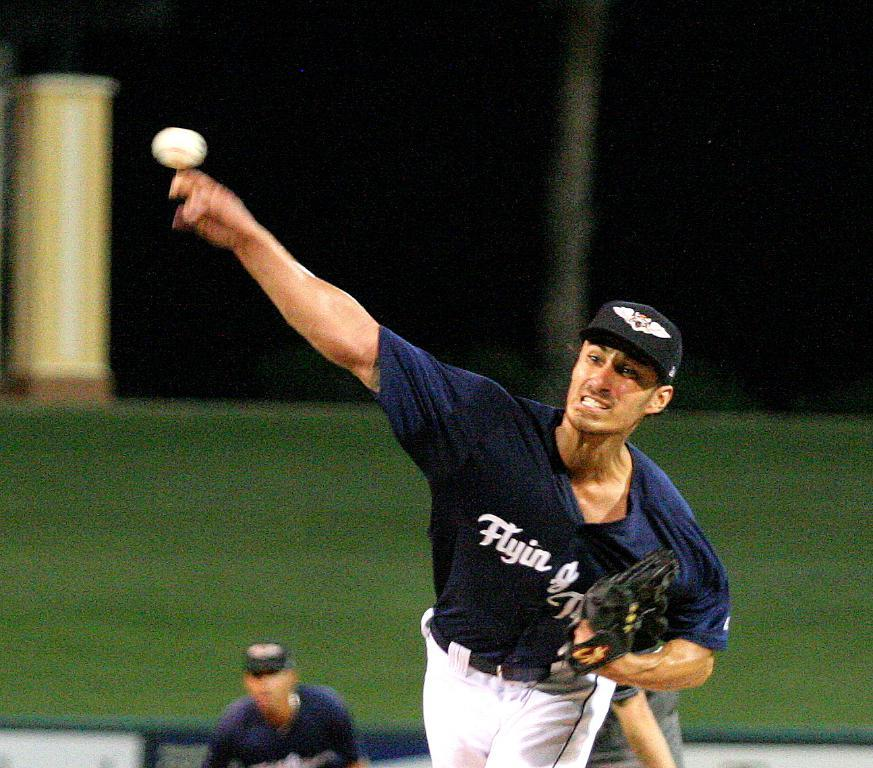<image>
Give a short and clear explanation of the subsequent image. A baseball player catches the ball in a jersey labeled "Flying." 